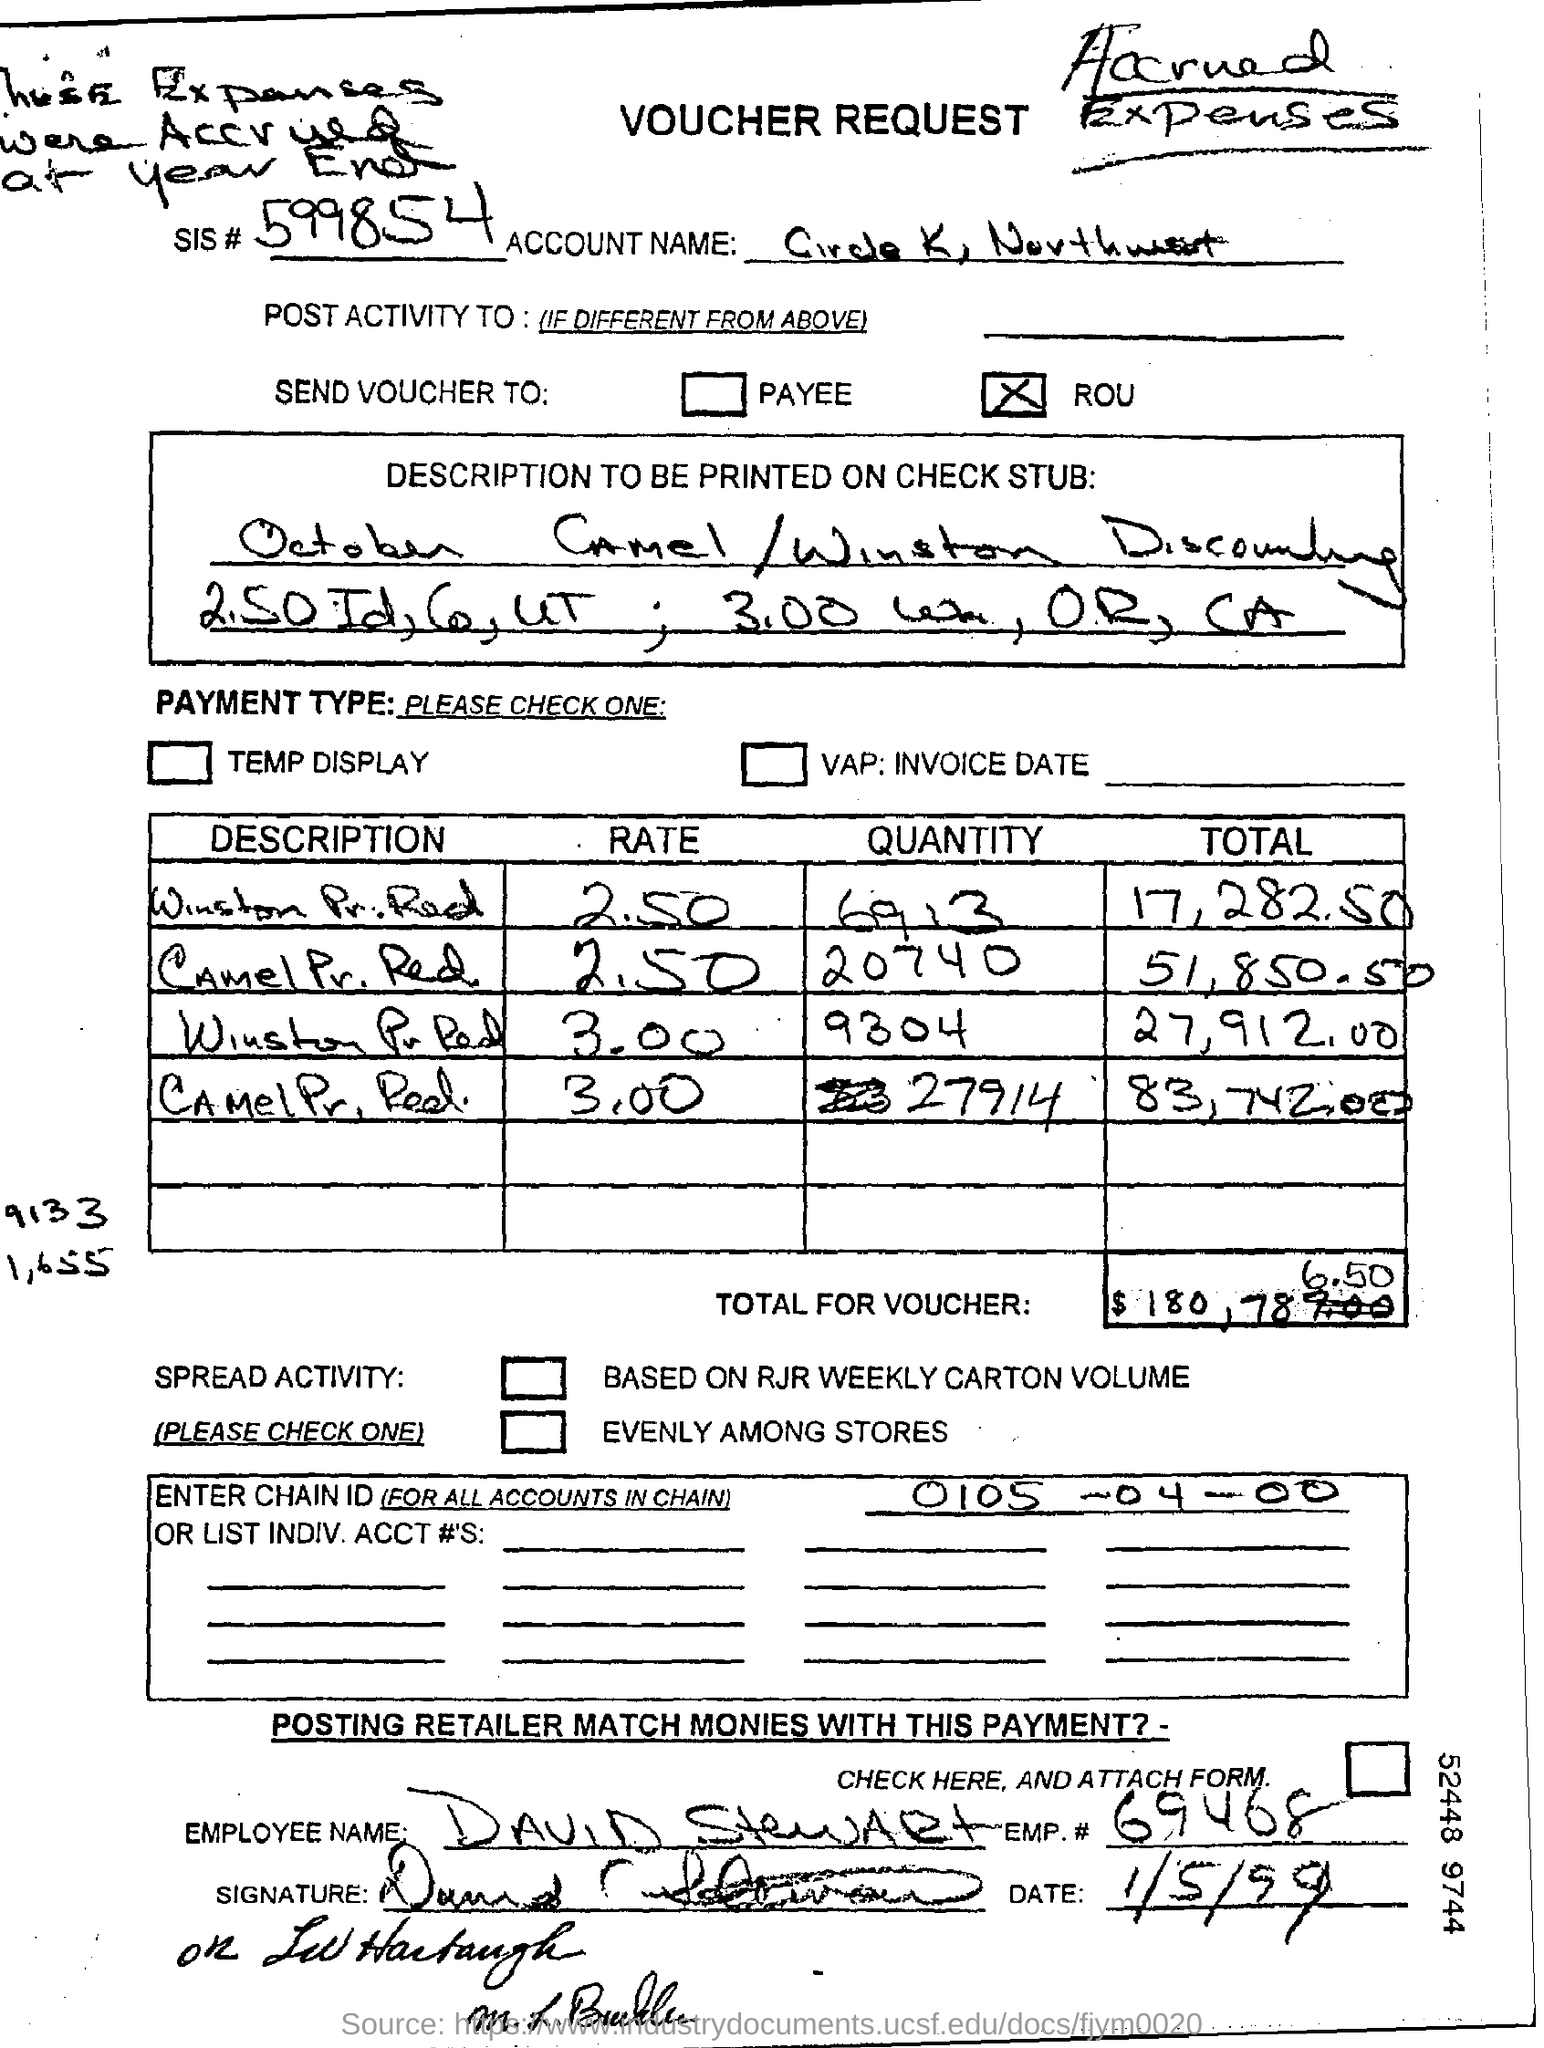What is the code for the sis#?
Ensure brevity in your answer.  599854. What is the name of employee ?
Make the answer very short. DAVID STEWART. 